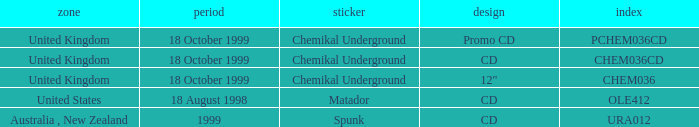Could you parse the entire table as a dict? {'header': ['zone', 'period', 'sticker', 'design', 'index'], 'rows': [['United Kingdom', '18 October 1999', 'Chemikal Underground', 'Promo CD', 'PCHEM036CD'], ['United Kingdom', '18 October 1999', 'Chemikal Underground', 'CD', 'CHEM036CD'], ['United Kingdom', '18 October 1999', 'Chemikal Underground', '12"', 'CHEM036'], ['United States', '18 August 1998', 'Matador', 'CD', 'OLE412'], ['Australia , New Zealand', '1999', 'Spunk', 'CD', 'URA012']]} What date is associated with the Spunk label? 1999.0. 